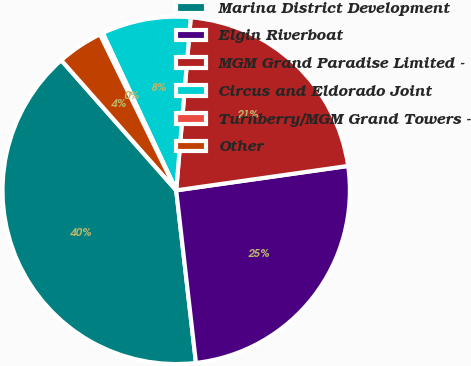<chart> <loc_0><loc_0><loc_500><loc_500><pie_chart><fcel>Marina District Development<fcel>Elgin Riverboat<fcel>MGM Grand Paradise Limited -<fcel>Circus and Eldorado Joint<fcel>Turnberry/MGM Grand Towers -<fcel>Other<nl><fcel>40.3%<fcel>25.43%<fcel>21.42%<fcel>8.29%<fcel>0.28%<fcel>4.28%<nl></chart> 